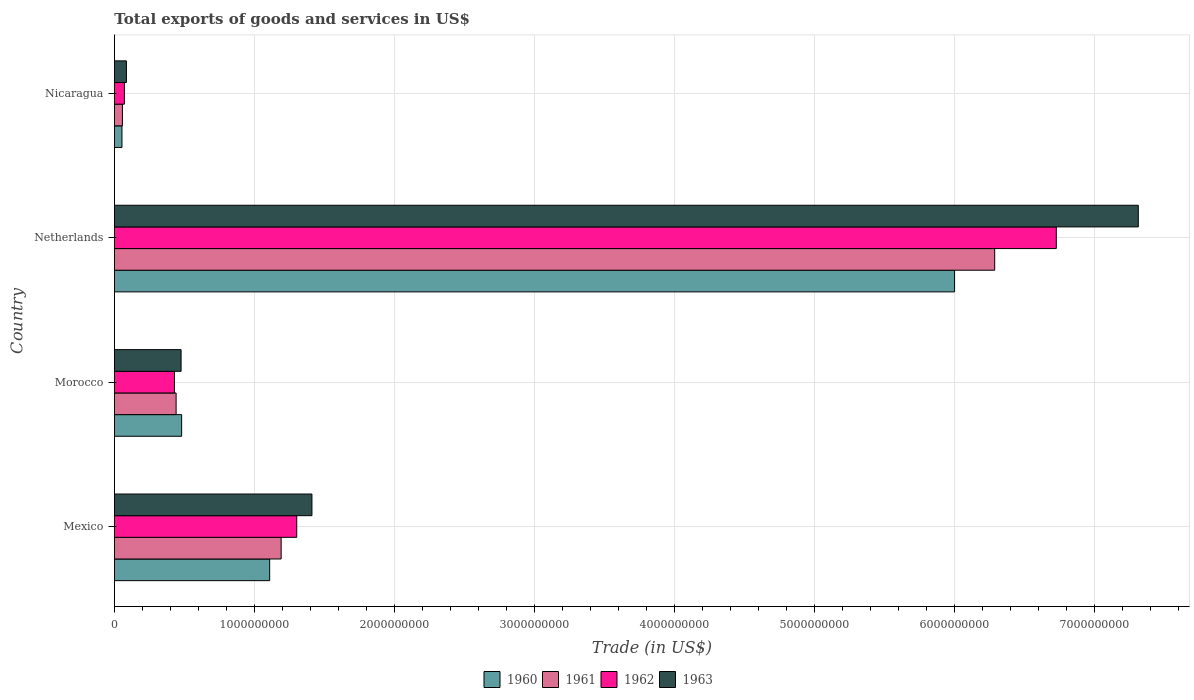How many different coloured bars are there?
Keep it short and to the point. 4. Are the number of bars per tick equal to the number of legend labels?
Offer a terse response. Yes. Are the number of bars on each tick of the Y-axis equal?
Provide a short and direct response. Yes. How many bars are there on the 2nd tick from the top?
Your answer should be very brief. 4. What is the label of the 4th group of bars from the top?
Ensure brevity in your answer.  Mexico. What is the total exports of goods and services in 1961 in Netherlands?
Make the answer very short. 6.29e+09. Across all countries, what is the maximum total exports of goods and services in 1963?
Keep it short and to the point. 7.32e+09. Across all countries, what is the minimum total exports of goods and services in 1960?
Your answer should be compact. 5.37e+07. In which country was the total exports of goods and services in 1960 maximum?
Keep it short and to the point. Netherlands. In which country was the total exports of goods and services in 1960 minimum?
Make the answer very short. Nicaragua. What is the total total exports of goods and services in 1962 in the graph?
Provide a short and direct response. 8.53e+09. What is the difference between the total exports of goods and services in 1962 in Morocco and that in Nicaragua?
Provide a short and direct response. 3.58e+08. What is the difference between the total exports of goods and services in 1961 in Morocco and the total exports of goods and services in 1962 in Mexico?
Provide a succinct answer. -8.62e+08. What is the average total exports of goods and services in 1961 per country?
Your answer should be very brief. 1.99e+09. What is the difference between the total exports of goods and services in 1962 and total exports of goods and services in 1960 in Netherlands?
Your answer should be compact. 7.27e+08. In how many countries, is the total exports of goods and services in 1963 greater than 5800000000 US$?
Your answer should be compact. 1. What is the ratio of the total exports of goods and services in 1962 in Morocco to that in Netherlands?
Your response must be concise. 0.06. Is the total exports of goods and services in 1963 in Mexico less than that in Morocco?
Give a very brief answer. No. What is the difference between the highest and the second highest total exports of goods and services in 1962?
Your answer should be very brief. 5.43e+09. What is the difference between the highest and the lowest total exports of goods and services in 1962?
Give a very brief answer. 6.66e+09. In how many countries, is the total exports of goods and services in 1963 greater than the average total exports of goods and services in 1963 taken over all countries?
Provide a short and direct response. 1. Is the sum of the total exports of goods and services in 1963 in Mexico and Netherlands greater than the maximum total exports of goods and services in 1961 across all countries?
Your answer should be compact. Yes. Is it the case that in every country, the sum of the total exports of goods and services in 1961 and total exports of goods and services in 1962 is greater than the sum of total exports of goods and services in 1963 and total exports of goods and services in 1960?
Make the answer very short. No. What does the 2nd bar from the top in Nicaragua represents?
Ensure brevity in your answer.  1962. What does the 4th bar from the bottom in Netherlands represents?
Your answer should be very brief. 1963. Is it the case that in every country, the sum of the total exports of goods and services in 1961 and total exports of goods and services in 1963 is greater than the total exports of goods and services in 1962?
Ensure brevity in your answer.  Yes. How many bars are there?
Your answer should be compact. 16. How many countries are there in the graph?
Give a very brief answer. 4. Does the graph contain any zero values?
Ensure brevity in your answer.  No. What is the title of the graph?
Your answer should be compact. Total exports of goods and services in US$. Does "2002" appear as one of the legend labels in the graph?
Give a very brief answer. No. What is the label or title of the X-axis?
Your answer should be compact. Trade (in US$). What is the Trade (in US$) in 1960 in Mexico?
Your answer should be compact. 1.11e+09. What is the Trade (in US$) in 1961 in Mexico?
Make the answer very short. 1.19e+09. What is the Trade (in US$) in 1962 in Mexico?
Offer a terse response. 1.30e+09. What is the Trade (in US$) in 1963 in Mexico?
Keep it short and to the point. 1.41e+09. What is the Trade (in US$) in 1960 in Morocco?
Make the answer very short. 4.80e+08. What is the Trade (in US$) in 1961 in Morocco?
Your response must be concise. 4.41e+08. What is the Trade (in US$) in 1962 in Morocco?
Offer a terse response. 4.29e+08. What is the Trade (in US$) in 1963 in Morocco?
Make the answer very short. 4.76e+08. What is the Trade (in US$) of 1960 in Netherlands?
Provide a short and direct response. 6.00e+09. What is the Trade (in US$) in 1961 in Netherlands?
Offer a very short reply. 6.29e+09. What is the Trade (in US$) of 1962 in Netherlands?
Your response must be concise. 6.73e+09. What is the Trade (in US$) in 1963 in Netherlands?
Provide a succinct answer. 7.32e+09. What is the Trade (in US$) of 1960 in Nicaragua?
Ensure brevity in your answer.  5.37e+07. What is the Trade (in US$) of 1961 in Nicaragua?
Your answer should be compact. 5.71e+07. What is the Trade (in US$) in 1962 in Nicaragua?
Provide a succinct answer. 7.12e+07. What is the Trade (in US$) of 1963 in Nicaragua?
Your answer should be very brief. 8.57e+07. Across all countries, what is the maximum Trade (in US$) in 1960?
Provide a succinct answer. 6.00e+09. Across all countries, what is the maximum Trade (in US$) of 1961?
Offer a terse response. 6.29e+09. Across all countries, what is the maximum Trade (in US$) in 1962?
Make the answer very short. 6.73e+09. Across all countries, what is the maximum Trade (in US$) of 1963?
Offer a very short reply. 7.32e+09. Across all countries, what is the minimum Trade (in US$) in 1960?
Offer a terse response. 5.37e+07. Across all countries, what is the minimum Trade (in US$) in 1961?
Provide a succinct answer. 5.71e+07. Across all countries, what is the minimum Trade (in US$) of 1962?
Give a very brief answer. 7.12e+07. Across all countries, what is the minimum Trade (in US$) in 1963?
Offer a very short reply. 8.57e+07. What is the total Trade (in US$) in 1960 in the graph?
Keep it short and to the point. 7.65e+09. What is the total Trade (in US$) of 1961 in the graph?
Give a very brief answer. 7.98e+09. What is the total Trade (in US$) of 1962 in the graph?
Your response must be concise. 8.53e+09. What is the total Trade (in US$) in 1963 in the graph?
Keep it short and to the point. 9.29e+09. What is the difference between the Trade (in US$) of 1960 in Mexico and that in Morocco?
Make the answer very short. 6.29e+08. What is the difference between the Trade (in US$) in 1961 in Mexico and that in Morocco?
Offer a very short reply. 7.51e+08. What is the difference between the Trade (in US$) of 1962 in Mexico and that in Morocco?
Offer a terse response. 8.74e+08. What is the difference between the Trade (in US$) of 1963 in Mexico and that in Morocco?
Give a very brief answer. 9.35e+08. What is the difference between the Trade (in US$) in 1960 in Mexico and that in Netherlands?
Your answer should be compact. -4.89e+09. What is the difference between the Trade (in US$) in 1961 in Mexico and that in Netherlands?
Ensure brevity in your answer.  -5.10e+09. What is the difference between the Trade (in US$) of 1962 in Mexico and that in Netherlands?
Make the answer very short. -5.43e+09. What is the difference between the Trade (in US$) in 1963 in Mexico and that in Netherlands?
Make the answer very short. -5.90e+09. What is the difference between the Trade (in US$) in 1960 in Mexico and that in Nicaragua?
Your response must be concise. 1.06e+09. What is the difference between the Trade (in US$) of 1961 in Mexico and that in Nicaragua?
Your response must be concise. 1.13e+09. What is the difference between the Trade (in US$) of 1962 in Mexico and that in Nicaragua?
Provide a succinct answer. 1.23e+09. What is the difference between the Trade (in US$) of 1963 in Mexico and that in Nicaragua?
Give a very brief answer. 1.33e+09. What is the difference between the Trade (in US$) of 1960 in Morocco and that in Netherlands?
Offer a terse response. -5.52e+09. What is the difference between the Trade (in US$) in 1961 in Morocco and that in Netherlands?
Ensure brevity in your answer.  -5.85e+09. What is the difference between the Trade (in US$) in 1962 in Morocco and that in Netherlands?
Your response must be concise. -6.30e+09. What is the difference between the Trade (in US$) in 1963 in Morocco and that in Netherlands?
Make the answer very short. -6.84e+09. What is the difference between the Trade (in US$) of 1960 in Morocco and that in Nicaragua?
Offer a terse response. 4.26e+08. What is the difference between the Trade (in US$) of 1961 in Morocco and that in Nicaragua?
Provide a succinct answer. 3.84e+08. What is the difference between the Trade (in US$) in 1962 in Morocco and that in Nicaragua?
Make the answer very short. 3.58e+08. What is the difference between the Trade (in US$) of 1963 in Morocco and that in Nicaragua?
Keep it short and to the point. 3.91e+08. What is the difference between the Trade (in US$) in 1960 in Netherlands and that in Nicaragua?
Make the answer very short. 5.95e+09. What is the difference between the Trade (in US$) of 1961 in Netherlands and that in Nicaragua?
Make the answer very short. 6.23e+09. What is the difference between the Trade (in US$) of 1962 in Netherlands and that in Nicaragua?
Your answer should be very brief. 6.66e+09. What is the difference between the Trade (in US$) of 1963 in Netherlands and that in Nicaragua?
Provide a succinct answer. 7.23e+09. What is the difference between the Trade (in US$) in 1960 in Mexico and the Trade (in US$) in 1961 in Morocco?
Offer a terse response. 6.68e+08. What is the difference between the Trade (in US$) of 1960 in Mexico and the Trade (in US$) of 1962 in Morocco?
Ensure brevity in your answer.  6.80e+08. What is the difference between the Trade (in US$) of 1960 in Mexico and the Trade (in US$) of 1963 in Morocco?
Your response must be concise. 6.33e+08. What is the difference between the Trade (in US$) in 1961 in Mexico and the Trade (in US$) in 1962 in Morocco?
Provide a succinct answer. 7.62e+08. What is the difference between the Trade (in US$) of 1961 in Mexico and the Trade (in US$) of 1963 in Morocco?
Your answer should be very brief. 7.15e+08. What is the difference between the Trade (in US$) in 1962 in Mexico and the Trade (in US$) in 1963 in Morocco?
Provide a short and direct response. 8.26e+08. What is the difference between the Trade (in US$) of 1960 in Mexico and the Trade (in US$) of 1961 in Netherlands?
Your answer should be compact. -5.18e+09. What is the difference between the Trade (in US$) of 1960 in Mexico and the Trade (in US$) of 1962 in Netherlands?
Make the answer very short. -5.62e+09. What is the difference between the Trade (in US$) of 1960 in Mexico and the Trade (in US$) of 1963 in Netherlands?
Offer a very short reply. -6.21e+09. What is the difference between the Trade (in US$) of 1961 in Mexico and the Trade (in US$) of 1962 in Netherlands?
Your answer should be compact. -5.54e+09. What is the difference between the Trade (in US$) of 1961 in Mexico and the Trade (in US$) of 1963 in Netherlands?
Offer a terse response. -6.12e+09. What is the difference between the Trade (in US$) in 1962 in Mexico and the Trade (in US$) in 1963 in Netherlands?
Offer a terse response. -6.01e+09. What is the difference between the Trade (in US$) in 1960 in Mexico and the Trade (in US$) in 1961 in Nicaragua?
Your response must be concise. 1.05e+09. What is the difference between the Trade (in US$) in 1960 in Mexico and the Trade (in US$) in 1962 in Nicaragua?
Offer a terse response. 1.04e+09. What is the difference between the Trade (in US$) of 1960 in Mexico and the Trade (in US$) of 1963 in Nicaragua?
Provide a short and direct response. 1.02e+09. What is the difference between the Trade (in US$) of 1961 in Mexico and the Trade (in US$) of 1962 in Nicaragua?
Offer a terse response. 1.12e+09. What is the difference between the Trade (in US$) of 1961 in Mexico and the Trade (in US$) of 1963 in Nicaragua?
Ensure brevity in your answer.  1.11e+09. What is the difference between the Trade (in US$) of 1962 in Mexico and the Trade (in US$) of 1963 in Nicaragua?
Your response must be concise. 1.22e+09. What is the difference between the Trade (in US$) of 1960 in Morocco and the Trade (in US$) of 1961 in Netherlands?
Give a very brief answer. -5.81e+09. What is the difference between the Trade (in US$) of 1960 in Morocco and the Trade (in US$) of 1962 in Netherlands?
Ensure brevity in your answer.  -6.25e+09. What is the difference between the Trade (in US$) of 1960 in Morocco and the Trade (in US$) of 1963 in Netherlands?
Offer a very short reply. -6.83e+09. What is the difference between the Trade (in US$) of 1961 in Morocco and the Trade (in US$) of 1962 in Netherlands?
Your response must be concise. -6.29e+09. What is the difference between the Trade (in US$) in 1961 in Morocco and the Trade (in US$) in 1963 in Netherlands?
Provide a succinct answer. -6.87e+09. What is the difference between the Trade (in US$) in 1962 in Morocco and the Trade (in US$) in 1963 in Netherlands?
Provide a short and direct response. -6.89e+09. What is the difference between the Trade (in US$) of 1960 in Morocco and the Trade (in US$) of 1961 in Nicaragua?
Offer a very short reply. 4.23e+08. What is the difference between the Trade (in US$) of 1960 in Morocco and the Trade (in US$) of 1962 in Nicaragua?
Your response must be concise. 4.09e+08. What is the difference between the Trade (in US$) of 1960 in Morocco and the Trade (in US$) of 1963 in Nicaragua?
Make the answer very short. 3.94e+08. What is the difference between the Trade (in US$) of 1961 in Morocco and the Trade (in US$) of 1962 in Nicaragua?
Keep it short and to the point. 3.69e+08. What is the difference between the Trade (in US$) in 1961 in Morocco and the Trade (in US$) in 1963 in Nicaragua?
Ensure brevity in your answer.  3.55e+08. What is the difference between the Trade (in US$) in 1962 in Morocco and the Trade (in US$) in 1963 in Nicaragua?
Keep it short and to the point. 3.43e+08. What is the difference between the Trade (in US$) of 1960 in Netherlands and the Trade (in US$) of 1961 in Nicaragua?
Your response must be concise. 5.95e+09. What is the difference between the Trade (in US$) in 1960 in Netherlands and the Trade (in US$) in 1962 in Nicaragua?
Your response must be concise. 5.93e+09. What is the difference between the Trade (in US$) in 1960 in Netherlands and the Trade (in US$) in 1963 in Nicaragua?
Give a very brief answer. 5.92e+09. What is the difference between the Trade (in US$) in 1961 in Netherlands and the Trade (in US$) in 1962 in Nicaragua?
Keep it short and to the point. 6.22e+09. What is the difference between the Trade (in US$) in 1961 in Netherlands and the Trade (in US$) in 1963 in Nicaragua?
Ensure brevity in your answer.  6.20e+09. What is the difference between the Trade (in US$) of 1962 in Netherlands and the Trade (in US$) of 1963 in Nicaragua?
Offer a very short reply. 6.64e+09. What is the average Trade (in US$) in 1960 per country?
Keep it short and to the point. 1.91e+09. What is the average Trade (in US$) of 1961 per country?
Provide a succinct answer. 1.99e+09. What is the average Trade (in US$) of 1962 per country?
Make the answer very short. 2.13e+09. What is the average Trade (in US$) in 1963 per country?
Make the answer very short. 2.32e+09. What is the difference between the Trade (in US$) in 1960 and Trade (in US$) in 1961 in Mexico?
Your answer should be very brief. -8.21e+07. What is the difference between the Trade (in US$) in 1960 and Trade (in US$) in 1962 in Mexico?
Give a very brief answer. -1.93e+08. What is the difference between the Trade (in US$) in 1960 and Trade (in US$) in 1963 in Mexico?
Offer a very short reply. -3.02e+08. What is the difference between the Trade (in US$) in 1961 and Trade (in US$) in 1962 in Mexico?
Your answer should be compact. -1.11e+08. What is the difference between the Trade (in US$) of 1961 and Trade (in US$) of 1963 in Mexico?
Offer a terse response. -2.20e+08. What is the difference between the Trade (in US$) of 1962 and Trade (in US$) of 1963 in Mexico?
Provide a succinct answer. -1.09e+08. What is the difference between the Trade (in US$) in 1960 and Trade (in US$) in 1961 in Morocco?
Your response must be concise. 3.95e+07. What is the difference between the Trade (in US$) of 1960 and Trade (in US$) of 1962 in Morocco?
Provide a succinct answer. 5.14e+07. What is the difference between the Trade (in US$) in 1960 and Trade (in US$) in 1963 in Morocco?
Provide a succinct answer. 3.95e+06. What is the difference between the Trade (in US$) in 1961 and Trade (in US$) in 1962 in Morocco?
Offer a very short reply. 1.19e+07. What is the difference between the Trade (in US$) in 1961 and Trade (in US$) in 1963 in Morocco?
Keep it short and to the point. -3.56e+07. What is the difference between the Trade (in US$) of 1962 and Trade (in US$) of 1963 in Morocco?
Provide a succinct answer. -4.74e+07. What is the difference between the Trade (in US$) of 1960 and Trade (in US$) of 1961 in Netherlands?
Make the answer very short. -2.87e+08. What is the difference between the Trade (in US$) in 1960 and Trade (in US$) in 1962 in Netherlands?
Offer a terse response. -7.27e+08. What is the difference between the Trade (in US$) in 1960 and Trade (in US$) in 1963 in Netherlands?
Keep it short and to the point. -1.31e+09. What is the difference between the Trade (in US$) of 1961 and Trade (in US$) of 1962 in Netherlands?
Offer a very short reply. -4.40e+08. What is the difference between the Trade (in US$) in 1961 and Trade (in US$) in 1963 in Netherlands?
Provide a succinct answer. -1.03e+09. What is the difference between the Trade (in US$) in 1962 and Trade (in US$) in 1963 in Netherlands?
Provide a short and direct response. -5.86e+08. What is the difference between the Trade (in US$) of 1960 and Trade (in US$) of 1961 in Nicaragua?
Your answer should be very brief. -3.39e+06. What is the difference between the Trade (in US$) in 1960 and Trade (in US$) in 1962 in Nicaragua?
Offer a very short reply. -1.74e+07. What is the difference between the Trade (in US$) of 1960 and Trade (in US$) of 1963 in Nicaragua?
Your answer should be compact. -3.20e+07. What is the difference between the Trade (in US$) in 1961 and Trade (in US$) in 1962 in Nicaragua?
Offer a very short reply. -1.40e+07. What is the difference between the Trade (in US$) of 1961 and Trade (in US$) of 1963 in Nicaragua?
Make the answer very short. -2.86e+07. What is the difference between the Trade (in US$) in 1962 and Trade (in US$) in 1963 in Nicaragua?
Make the answer very short. -1.45e+07. What is the ratio of the Trade (in US$) of 1960 in Mexico to that in Morocco?
Offer a terse response. 2.31. What is the ratio of the Trade (in US$) of 1961 in Mexico to that in Morocco?
Your response must be concise. 2.7. What is the ratio of the Trade (in US$) in 1962 in Mexico to that in Morocco?
Ensure brevity in your answer.  3.04. What is the ratio of the Trade (in US$) of 1963 in Mexico to that in Morocco?
Give a very brief answer. 2.96. What is the ratio of the Trade (in US$) of 1960 in Mexico to that in Netherlands?
Ensure brevity in your answer.  0.18. What is the ratio of the Trade (in US$) in 1961 in Mexico to that in Netherlands?
Provide a succinct answer. 0.19. What is the ratio of the Trade (in US$) in 1962 in Mexico to that in Netherlands?
Make the answer very short. 0.19. What is the ratio of the Trade (in US$) in 1963 in Mexico to that in Netherlands?
Offer a very short reply. 0.19. What is the ratio of the Trade (in US$) of 1960 in Mexico to that in Nicaragua?
Your answer should be very brief. 20.64. What is the ratio of the Trade (in US$) in 1961 in Mexico to that in Nicaragua?
Your answer should be compact. 20.85. What is the ratio of the Trade (in US$) of 1962 in Mexico to that in Nicaragua?
Your answer should be compact. 18.3. What is the ratio of the Trade (in US$) of 1963 in Mexico to that in Nicaragua?
Your response must be concise. 16.47. What is the ratio of the Trade (in US$) in 1961 in Morocco to that in Netherlands?
Make the answer very short. 0.07. What is the ratio of the Trade (in US$) in 1962 in Morocco to that in Netherlands?
Ensure brevity in your answer.  0.06. What is the ratio of the Trade (in US$) of 1963 in Morocco to that in Netherlands?
Make the answer very short. 0.07. What is the ratio of the Trade (in US$) in 1960 in Morocco to that in Nicaragua?
Provide a succinct answer. 8.93. What is the ratio of the Trade (in US$) in 1961 in Morocco to that in Nicaragua?
Ensure brevity in your answer.  7.71. What is the ratio of the Trade (in US$) in 1962 in Morocco to that in Nicaragua?
Offer a terse response. 6.02. What is the ratio of the Trade (in US$) of 1963 in Morocco to that in Nicaragua?
Your answer should be compact. 5.56. What is the ratio of the Trade (in US$) in 1960 in Netherlands to that in Nicaragua?
Your answer should be compact. 111.69. What is the ratio of the Trade (in US$) of 1961 in Netherlands to that in Nicaragua?
Provide a short and direct response. 110.08. What is the ratio of the Trade (in US$) in 1962 in Netherlands to that in Nicaragua?
Give a very brief answer. 94.54. What is the ratio of the Trade (in US$) in 1963 in Netherlands to that in Nicaragua?
Provide a short and direct response. 85.36. What is the difference between the highest and the second highest Trade (in US$) of 1960?
Your response must be concise. 4.89e+09. What is the difference between the highest and the second highest Trade (in US$) in 1961?
Your response must be concise. 5.10e+09. What is the difference between the highest and the second highest Trade (in US$) in 1962?
Keep it short and to the point. 5.43e+09. What is the difference between the highest and the second highest Trade (in US$) in 1963?
Make the answer very short. 5.90e+09. What is the difference between the highest and the lowest Trade (in US$) in 1960?
Provide a short and direct response. 5.95e+09. What is the difference between the highest and the lowest Trade (in US$) in 1961?
Make the answer very short. 6.23e+09. What is the difference between the highest and the lowest Trade (in US$) of 1962?
Make the answer very short. 6.66e+09. What is the difference between the highest and the lowest Trade (in US$) in 1963?
Your response must be concise. 7.23e+09. 